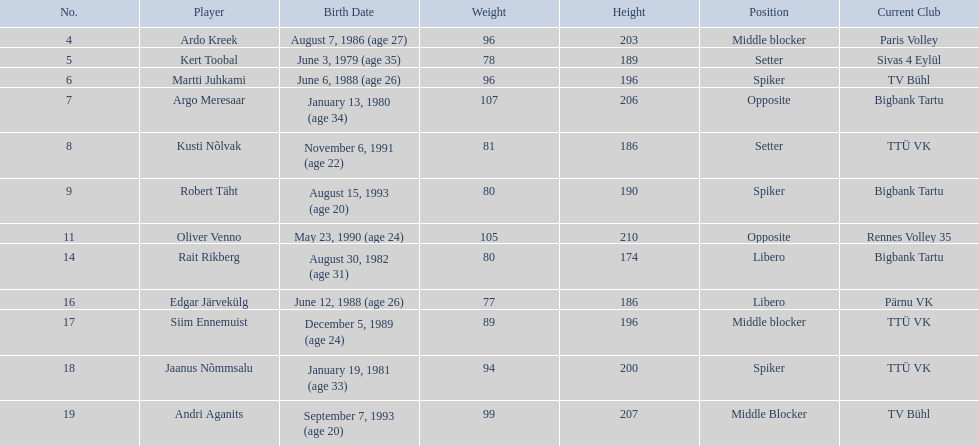Who are the players of the estonian men's national volleyball team? Ardo Kreek, Kert Toobal, Martti Juhkami, Argo Meresaar, Kusti Nõlvak, Robert Täht, Oliver Venno, Rait Rikberg, Edgar Järvekülg, Siim Ennemuist, Jaanus Nõmmsalu, Andri Aganits. Of these, which have a height over 200? Ardo Kreek, Argo Meresaar, Oliver Venno, Andri Aganits. Of the remaining, who is the tallest? Oliver Venno. 